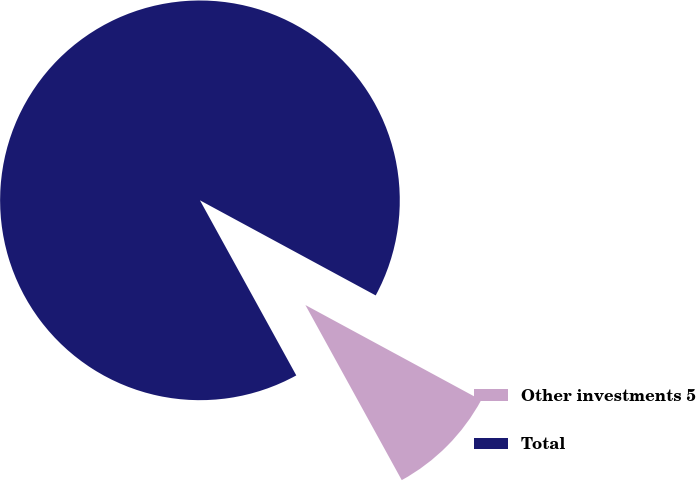Convert chart. <chart><loc_0><loc_0><loc_500><loc_500><pie_chart><fcel>Other investments 5<fcel>Total<nl><fcel>9.1%<fcel>90.9%<nl></chart> 